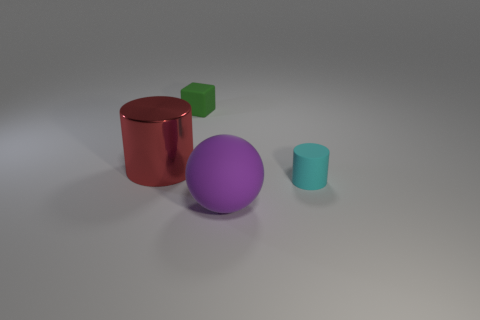Are there any other things that have the same material as the red object?
Ensure brevity in your answer.  No. Is there anything else that has the same shape as the green rubber thing?
Provide a succinct answer. No. Do the cylinder that is on the right side of the green block and the big thing that is in front of the cyan object have the same material?
Offer a very short reply. Yes. What is the big cylinder made of?
Provide a short and direct response. Metal. Are there more large red objects on the right side of the big cylinder than small gray metal objects?
Your answer should be very brief. No. How many big purple spheres are behind the cylinder that is on the right side of the rubber object in front of the cyan object?
Provide a succinct answer. 0. There is a thing that is in front of the big red object and on the left side of the cyan thing; what material is it?
Provide a short and direct response. Rubber. The matte cube is what color?
Make the answer very short. Green. Are there more shiny things that are behind the red cylinder than purple things behind the tiny rubber cylinder?
Make the answer very short. No. There is a tiny object that is in front of the large red cylinder; what color is it?
Provide a short and direct response. Cyan. 